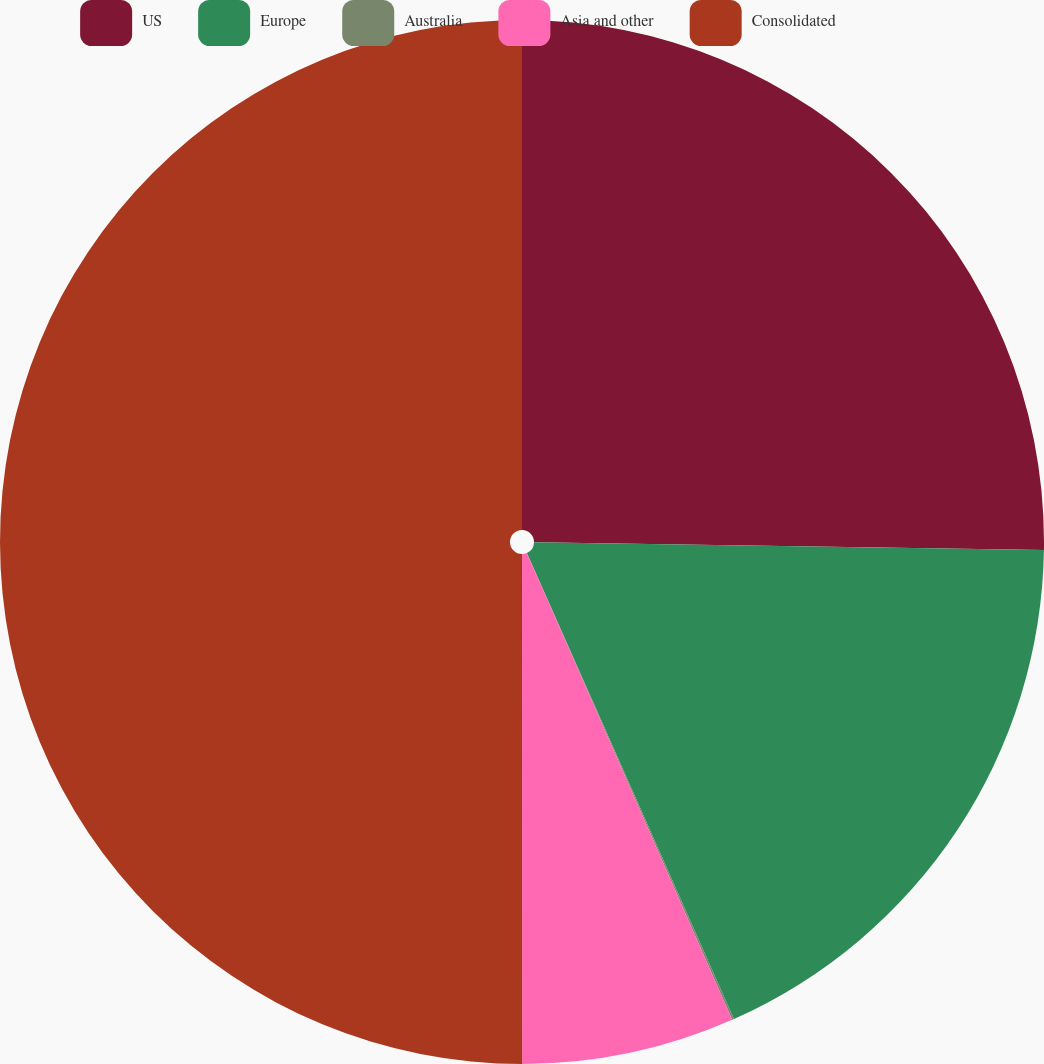<chart> <loc_0><loc_0><loc_500><loc_500><pie_chart><fcel>US<fcel>Europe<fcel>Australia<fcel>Asia and other<fcel>Consolidated<nl><fcel>25.24%<fcel>18.1%<fcel>0.06%<fcel>6.59%<fcel>50.0%<nl></chart> 